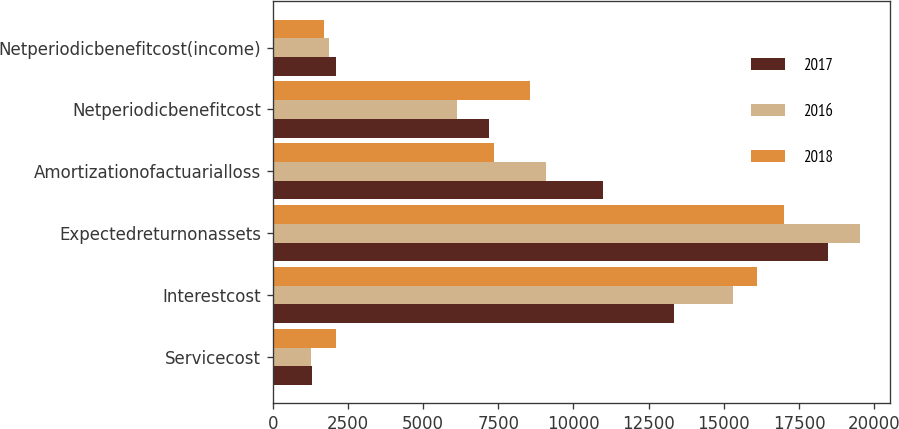Convert chart. <chart><loc_0><loc_0><loc_500><loc_500><stacked_bar_chart><ecel><fcel>Servicecost<fcel>Interestcost<fcel>Expectedreturnonassets<fcel>Amortizationofactuarialloss<fcel>Netperiodicbenefitcost<fcel>Netperiodicbenefitcost(income)<nl><fcel>2017<fcel>1300<fcel>13358<fcel>18475<fcel>10995<fcel>7178<fcel>2092<nl><fcel>2016<fcel>1290<fcel>15303<fcel>19534<fcel>9082<fcel>6141<fcel>1870<nl><fcel>2018<fcel>2100<fcel>16106<fcel>17013<fcel>7361<fcel>8554<fcel>1707<nl></chart> 